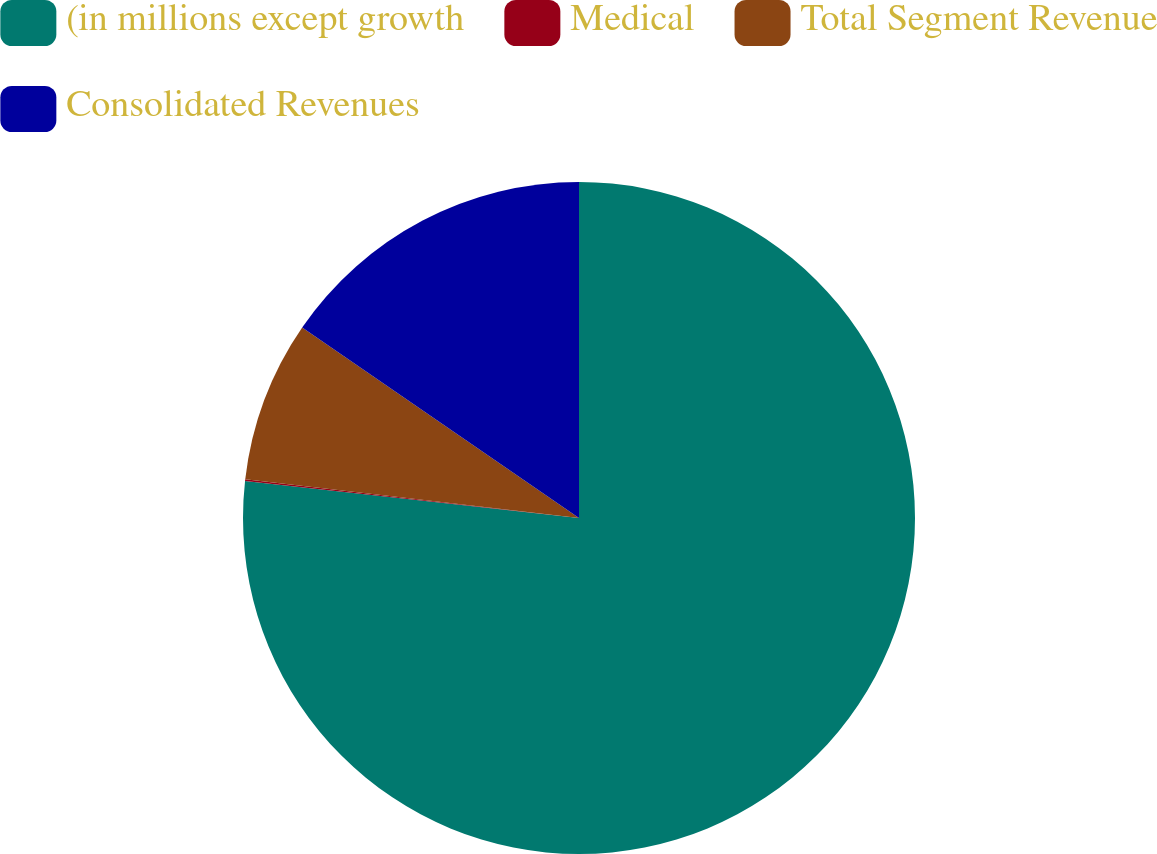Convert chart. <chart><loc_0><loc_0><loc_500><loc_500><pie_chart><fcel>(in millions except growth<fcel>Medical<fcel>Total Segment Revenue<fcel>Consolidated Revenues<nl><fcel>76.76%<fcel>0.08%<fcel>7.75%<fcel>15.41%<nl></chart> 